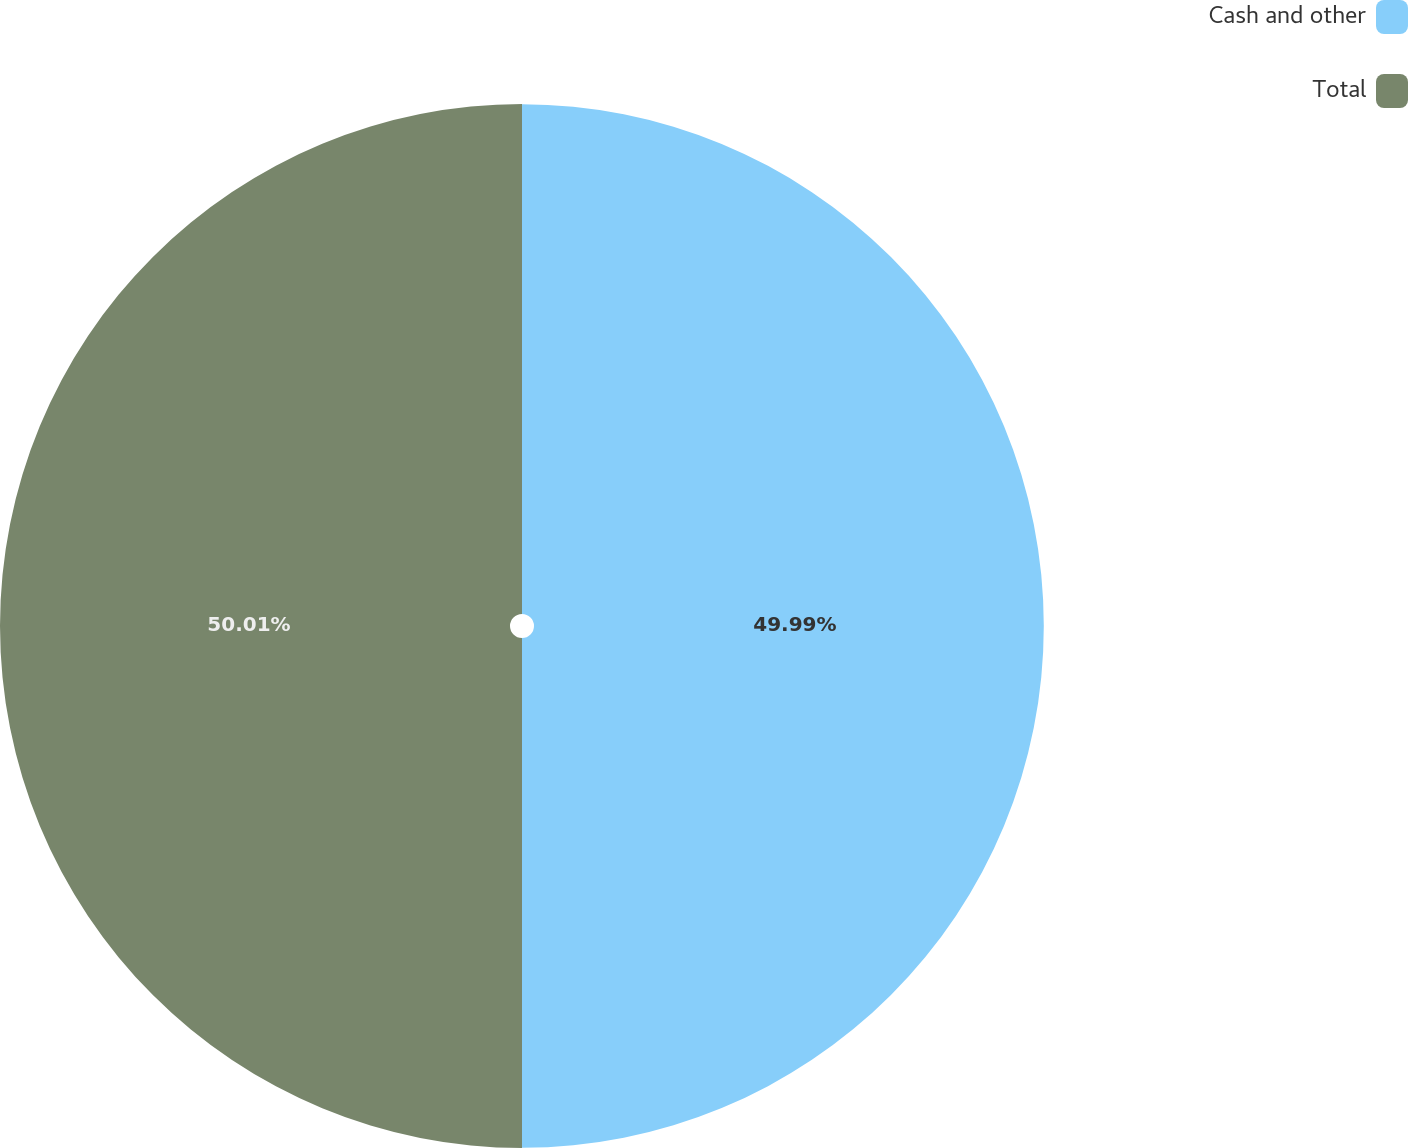Convert chart. <chart><loc_0><loc_0><loc_500><loc_500><pie_chart><fcel>Cash and other<fcel>Total<nl><fcel>49.99%<fcel>50.01%<nl></chart> 